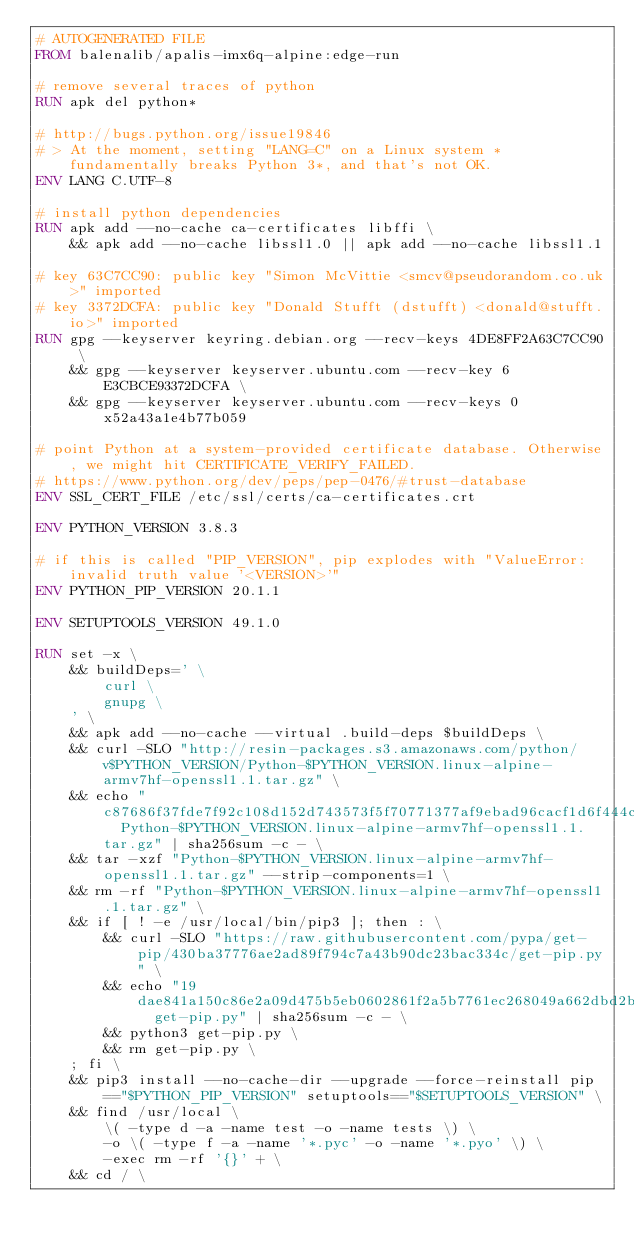Convert code to text. <code><loc_0><loc_0><loc_500><loc_500><_Dockerfile_># AUTOGENERATED FILE
FROM balenalib/apalis-imx6q-alpine:edge-run

# remove several traces of python
RUN apk del python*

# http://bugs.python.org/issue19846
# > At the moment, setting "LANG=C" on a Linux system *fundamentally breaks Python 3*, and that's not OK.
ENV LANG C.UTF-8

# install python dependencies
RUN apk add --no-cache ca-certificates libffi \
	&& apk add --no-cache libssl1.0 || apk add --no-cache libssl1.1

# key 63C7CC90: public key "Simon McVittie <smcv@pseudorandom.co.uk>" imported
# key 3372DCFA: public key "Donald Stufft (dstufft) <donald@stufft.io>" imported
RUN gpg --keyserver keyring.debian.org --recv-keys 4DE8FF2A63C7CC90 \
	&& gpg --keyserver keyserver.ubuntu.com --recv-key 6E3CBCE93372DCFA \
	&& gpg --keyserver keyserver.ubuntu.com --recv-keys 0x52a43a1e4b77b059

# point Python at a system-provided certificate database. Otherwise, we might hit CERTIFICATE_VERIFY_FAILED.
# https://www.python.org/dev/peps/pep-0476/#trust-database
ENV SSL_CERT_FILE /etc/ssl/certs/ca-certificates.crt

ENV PYTHON_VERSION 3.8.3

# if this is called "PIP_VERSION", pip explodes with "ValueError: invalid truth value '<VERSION>'"
ENV PYTHON_PIP_VERSION 20.1.1

ENV SETUPTOOLS_VERSION 49.1.0

RUN set -x \
	&& buildDeps=' \
		curl \
		gnupg \
	' \
	&& apk add --no-cache --virtual .build-deps $buildDeps \
	&& curl -SLO "http://resin-packages.s3.amazonaws.com/python/v$PYTHON_VERSION/Python-$PYTHON_VERSION.linux-alpine-armv7hf-openssl1.1.tar.gz" \
	&& echo "c87686f37fde7f92c108d152d743573f5f70771377af9ebad96cacf1d6f444cc  Python-$PYTHON_VERSION.linux-alpine-armv7hf-openssl1.1.tar.gz" | sha256sum -c - \
	&& tar -xzf "Python-$PYTHON_VERSION.linux-alpine-armv7hf-openssl1.1.tar.gz" --strip-components=1 \
	&& rm -rf "Python-$PYTHON_VERSION.linux-alpine-armv7hf-openssl1.1.tar.gz" \
	&& if [ ! -e /usr/local/bin/pip3 ]; then : \
		&& curl -SLO "https://raw.githubusercontent.com/pypa/get-pip/430ba37776ae2ad89f794c7a43b90dc23bac334c/get-pip.py" \
		&& echo "19dae841a150c86e2a09d475b5eb0602861f2a5b7761ec268049a662dbd2bd0c  get-pip.py" | sha256sum -c - \
		&& python3 get-pip.py \
		&& rm get-pip.py \
	; fi \
	&& pip3 install --no-cache-dir --upgrade --force-reinstall pip=="$PYTHON_PIP_VERSION" setuptools=="$SETUPTOOLS_VERSION" \
	&& find /usr/local \
		\( -type d -a -name test -o -name tests \) \
		-o \( -type f -a -name '*.pyc' -o -name '*.pyo' \) \
		-exec rm -rf '{}' + \
	&& cd / \</code> 